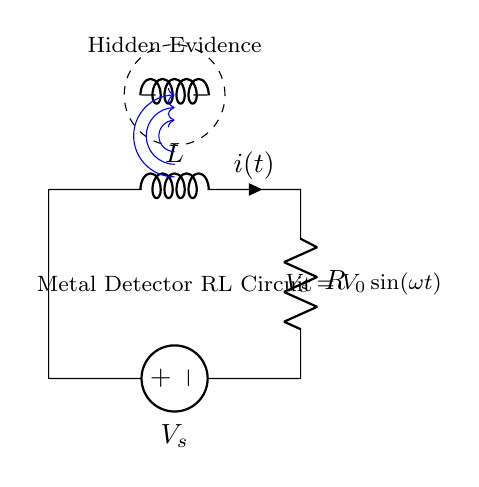What type of circuit is this? This circuit is an RL circuit, which comprises a resistor (R) and an inductor (L) in series, used for various applications, including metal detection.
Answer: RL circuit What does "V_s" represent in this circuit? The symbol "V_s" represents the source voltage in the circuit, denoted as a sine wave, indicating that the voltage varies sinusoidally over time.
Answer: Source voltage What component represents the hidden evidence? The hidden evidence is represented by a cute inductor drawn within a dashed circle, indicating that it's an important element being detected by the metal detector.
Answer: Coupled inductor What is the relationship between voltage and current in this RL circuit? In an RL circuit, the voltage across the inductor and resistor is related to the current through both components, resulting in a phase difference; specifically, the voltage leads the current.
Answer: Voltage leads current How does the inductance (L) affect the circuit’s response? The inductance (L) stores energy in a magnetic field when current flows through it, causing a delay in the circuit’s response to changes in voltage, making the circuit react more slowly to variations compared to a purely resistive circuit.
Answer: Delays circuit response What type of waves does "V_s" generate? "V_s" generates sinusoidal waves, indicated by the expression for voltage, which suggests a periodic input into the RL circuit, typically used to detect metals.
Answer: Sinusoidal waves What is the purpose of the metal detector circuit? The purpose of the metal detector circuit is to uncover hidden evidence by detecting changes in the magnetic field caused by conductive materials within the range of the detector.
Answer: Uncover hidden evidence 